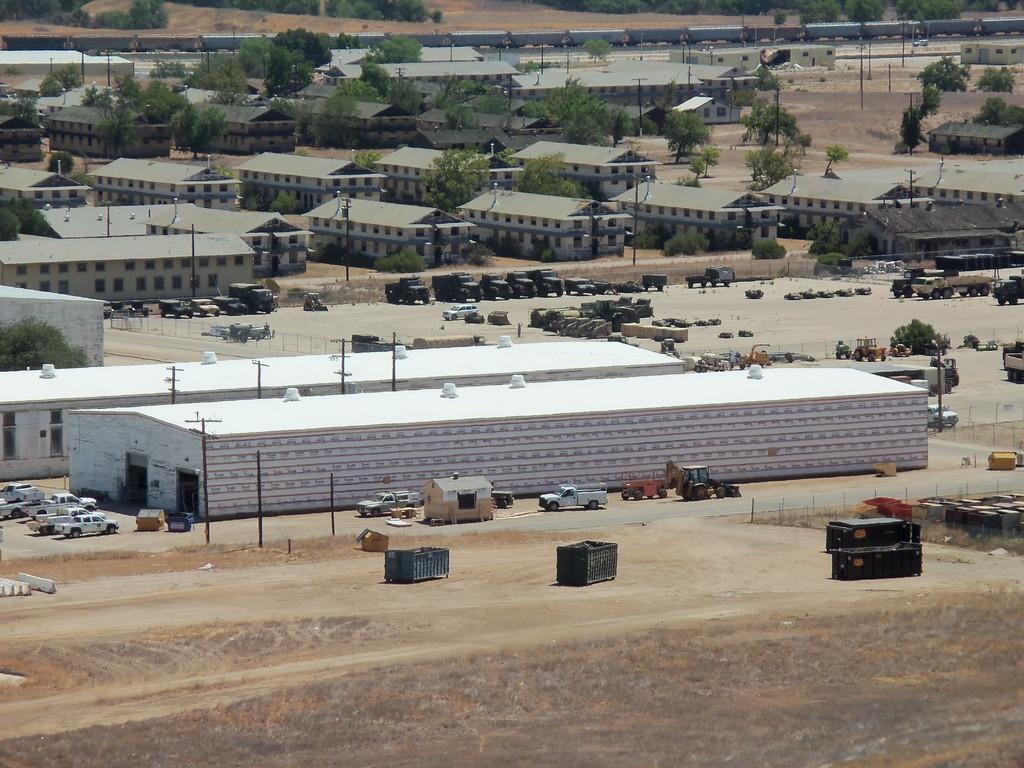How would you summarize this image in a sentence or two? This is an outside view. At the bottom, I can see the ground. Here I can see many houses, trees and vehicles on the ground and also there are some light poles. At the bottom there are few containers placed on the ground. 